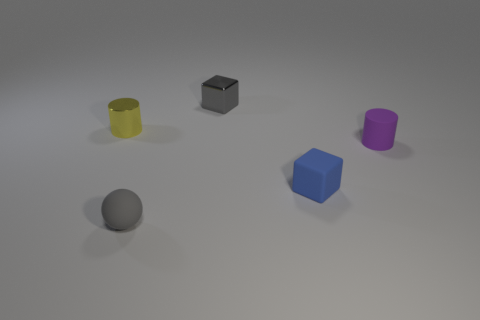There is a thing that is behind the tiny blue rubber block and right of the gray block; what is its color?
Offer a very short reply. Purple. Is the number of tiny purple matte objects less than the number of small red rubber blocks?
Make the answer very short. No. Is the color of the tiny matte sphere the same as the tiny matte object that is right of the rubber cube?
Ensure brevity in your answer.  No. Are there an equal number of cylinders that are on the right side of the small purple object and tiny gray cubes in front of the tiny gray block?
Make the answer very short. Yes. How many tiny rubber things are the same shape as the small gray shiny thing?
Offer a terse response. 1. Are any small yellow shiny objects visible?
Your answer should be very brief. Yes. Do the tiny purple thing and the tiny cylinder left of the gray metallic cube have the same material?
Make the answer very short. No. What material is the gray thing that is the same size as the sphere?
Your answer should be very brief. Metal. Are there any small gray blocks that have the same material as the small gray sphere?
Keep it short and to the point. No. There is a small cylinder to the right of the metal thing to the left of the tiny rubber ball; is there a tiny cylinder that is to the right of it?
Offer a very short reply. No. 